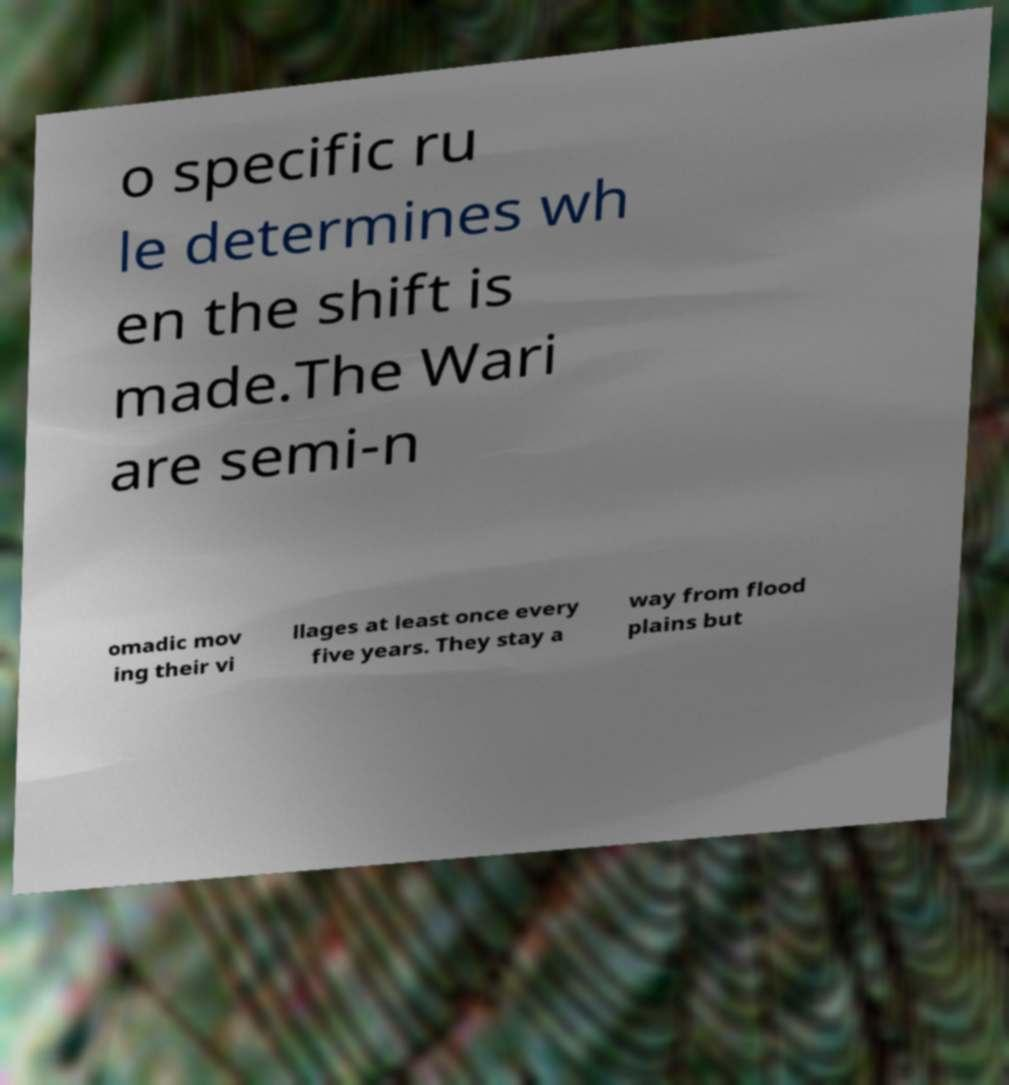There's text embedded in this image that I need extracted. Can you transcribe it verbatim? o specific ru le determines wh en the shift is made.The Wari are semi-n omadic mov ing their vi llages at least once every five years. They stay a way from flood plains but 